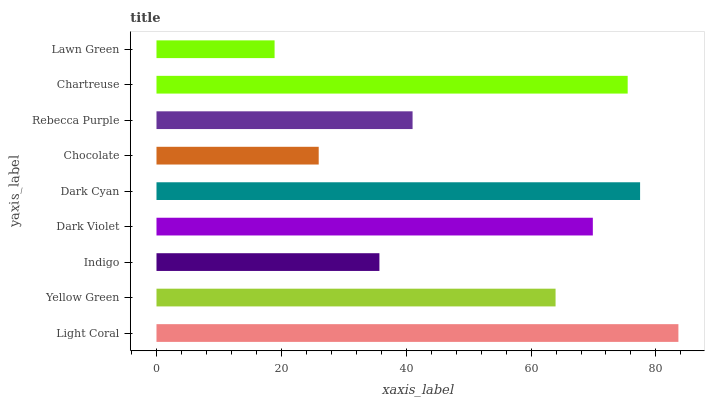Is Lawn Green the minimum?
Answer yes or no. Yes. Is Light Coral the maximum?
Answer yes or no. Yes. Is Yellow Green the minimum?
Answer yes or no. No. Is Yellow Green the maximum?
Answer yes or no. No. Is Light Coral greater than Yellow Green?
Answer yes or no. Yes. Is Yellow Green less than Light Coral?
Answer yes or no. Yes. Is Yellow Green greater than Light Coral?
Answer yes or no. No. Is Light Coral less than Yellow Green?
Answer yes or no. No. Is Yellow Green the high median?
Answer yes or no. Yes. Is Yellow Green the low median?
Answer yes or no. Yes. Is Dark Violet the high median?
Answer yes or no. No. Is Lawn Green the low median?
Answer yes or no. No. 